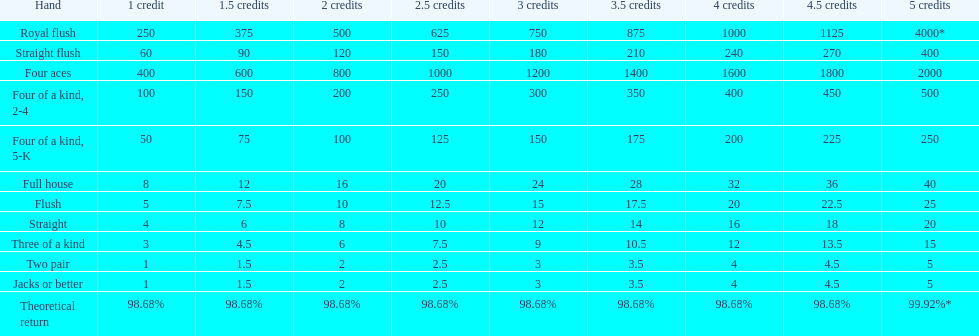What number is a multiple for every four aces victory? 400. 